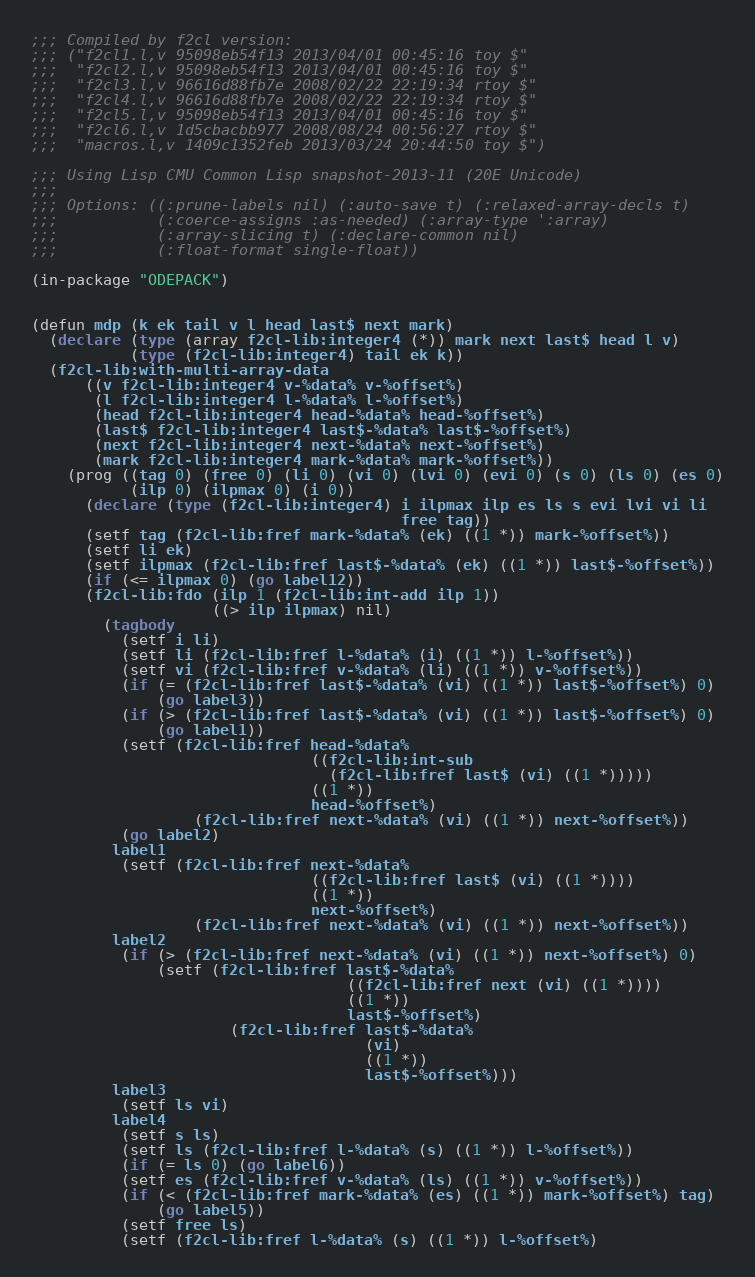Convert code to text. <code><loc_0><loc_0><loc_500><loc_500><_Lisp_>;;; Compiled by f2cl version:
;;; ("f2cl1.l,v 95098eb54f13 2013/04/01 00:45:16 toy $"
;;;  "f2cl2.l,v 95098eb54f13 2013/04/01 00:45:16 toy $"
;;;  "f2cl3.l,v 96616d88fb7e 2008/02/22 22:19:34 rtoy $"
;;;  "f2cl4.l,v 96616d88fb7e 2008/02/22 22:19:34 rtoy $"
;;;  "f2cl5.l,v 95098eb54f13 2013/04/01 00:45:16 toy $"
;;;  "f2cl6.l,v 1d5cbacbb977 2008/08/24 00:56:27 rtoy $"
;;;  "macros.l,v 1409c1352feb 2013/03/24 20:44:50 toy $")

;;; Using Lisp CMU Common Lisp snapshot-2013-11 (20E Unicode)
;;; 
;;; Options: ((:prune-labels nil) (:auto-save t) (:relaxed-array-decls t)
;;;           (:coerce-assigns :as-needed) (:array-type ':array)
;;;           (:array-slicing t) (:declare-common nil)
;;;           (:float-format single-float))

(in-package "ODEPACK")


(defun mdp (k ek tail v l head last$ next mark)
  (declare (type (array f2cl-lib:integer4 (*)) mark next last$ head l v)
           (type (f2cl-lib:integer4) tail ek k))
  (f2cl-lib:with-multi-array-data
      ((v f2cl-lib:integer4 v-%data% v-%offset%)
       (l f2cl-lib:integer4 l-%data% l-%offset%)
       (head f2cl-lib:integer4 head-%data% head-%offset%)
       (last$ f2cl-lib:integer4 last$-%data% last$-%offset%)
       (next f2cl-lib:integer4 next-%data% next-%offset%)
       (mark f2cl-lib:integer4 mark-%data% mark-%offset%))
    (prog ((tag 0) (free 0) (li 0) (vi 0) (lvi 0) (evi 0) (s 0) (ls 0) (es 0)
           (ilp 0) (ilpmax 0) (i 0))
      (declare (type (f2cl-lib:integer4) i ilpmax ilp es ls s evi lvi vi li
                                         free tag))
      (setf tag (f2cl-lib:fref mark-%data% (ek) ((1 *)) mark-%offset%))
      (setf li ek)
      (setf ilpmax (f2cl-lib:fref last$-%data% (ek) ((1 *)) last$-%offset%))
      (if (<= ilpmax 0) (go label12))
      (f2cl-lib:fdo (ilp 1 (f2cl-lib:int-add ilp 1))
                    ((> ilp ilpmax) nil)
        (tagbody
          (setf i li)
          (setf li (f2cl-lib:fref l-%data% (i) ((1 *)) l-%offset%))
          (setf vi (f2cl-lib:fref v-%data% (li) ((1 *)) v-%offset%))
          (if (= (f2cl-lib:fref last$-%data% (vi) ((1 *)) last$-%offset%) 0)
              (go label3))
          (if (> (f2cl-lib:fref last$-%data% (vi) ((1 *)) last$-%offset%) 0)
              (go label1))
          (setf (f2cl-lib:fref head-%data%
                               ((f2cl-lib:int-sub
                                 (f2cl-lib:fref last$ (vi) ((1 *)))))
                               ((1 *))
                               head-%offset%)
                  (f2cl-lib:fref next-%data% (vi) ((1 *)) next-%offset%))
          (go label2)
         label1
          (setf (f2cl-lib:fref next-%data%
                               ((f2cl-lib:fref last$ (vi) ((1 *))))
                               ((1 *))
                               next-%offset%)
                  (f2cl-lib:fref next-%data% (vi) ((1 *)) next-%offset%))
         label2
          (if (> (f2cl-lib:fref next-%data% (vi) ((1 *)) next-%offset%) 0)
              (setf (f2cl-lib:fref last$-%data%
                                   ((f2cl-lib:fref next (vi) ((1 *))))
                                   ((1 *))
                                   last$-%offset%)
                      (f2cl-lib:fref last$-%data%
                                     (vi)
                                     ((1 *))
                                     last$-%offset%)))
         label3
          (setf ls vi)
         label4
          (setf s ls)
          (setf ls (f2cl-lib:fref l-%data% (s) ((1 *)) l-%offset%))
          (if (= ls 0) (go label6))
          (setf es (f2cl-lib:fref v-%data% (ls) ((1 *)) v-%offset%))
          (if (< (f2cl-lib:fref mark-%data% (es) ((1 *)) mark-%offset%) tag)
              (go label5))
          (setf free ls)
          (setf (f2cl-lib:fref l-%data% (s) ((1 *)) l-%offset%)</code> 